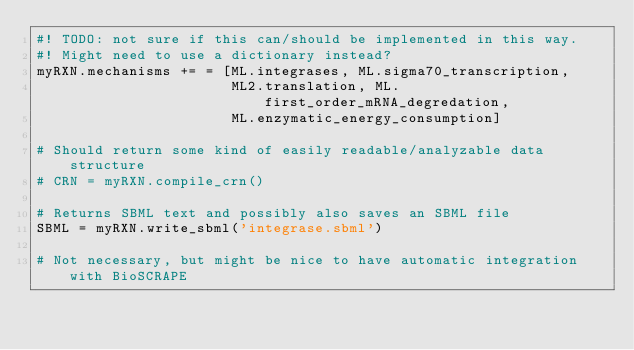Convert code to text. <code><loc_0><loc_0><loc_500><loc_500><_Python_>#! TODO: not sure if this can/should be implemented in this way.
#! Might need to use a dictionary instead?
myRXN.mechanisms += = [ML.integrases, ML.sigma70_transcription,
                       ML2.translation, ML.first_order_mRNA_degredation,
                       ML.enzymatic_energy_consumption] 

# Should return some kind of easily readable/analyzable data structure
# CRN = myRXN.compile_crn() 

# Returns SBML text and possibly also saves an SBML file
SBML = myRXN.write_sbml('integrase.sbml')

# Not necessary, but might be nice to have automatic integration with BioSCRAPE</code> 